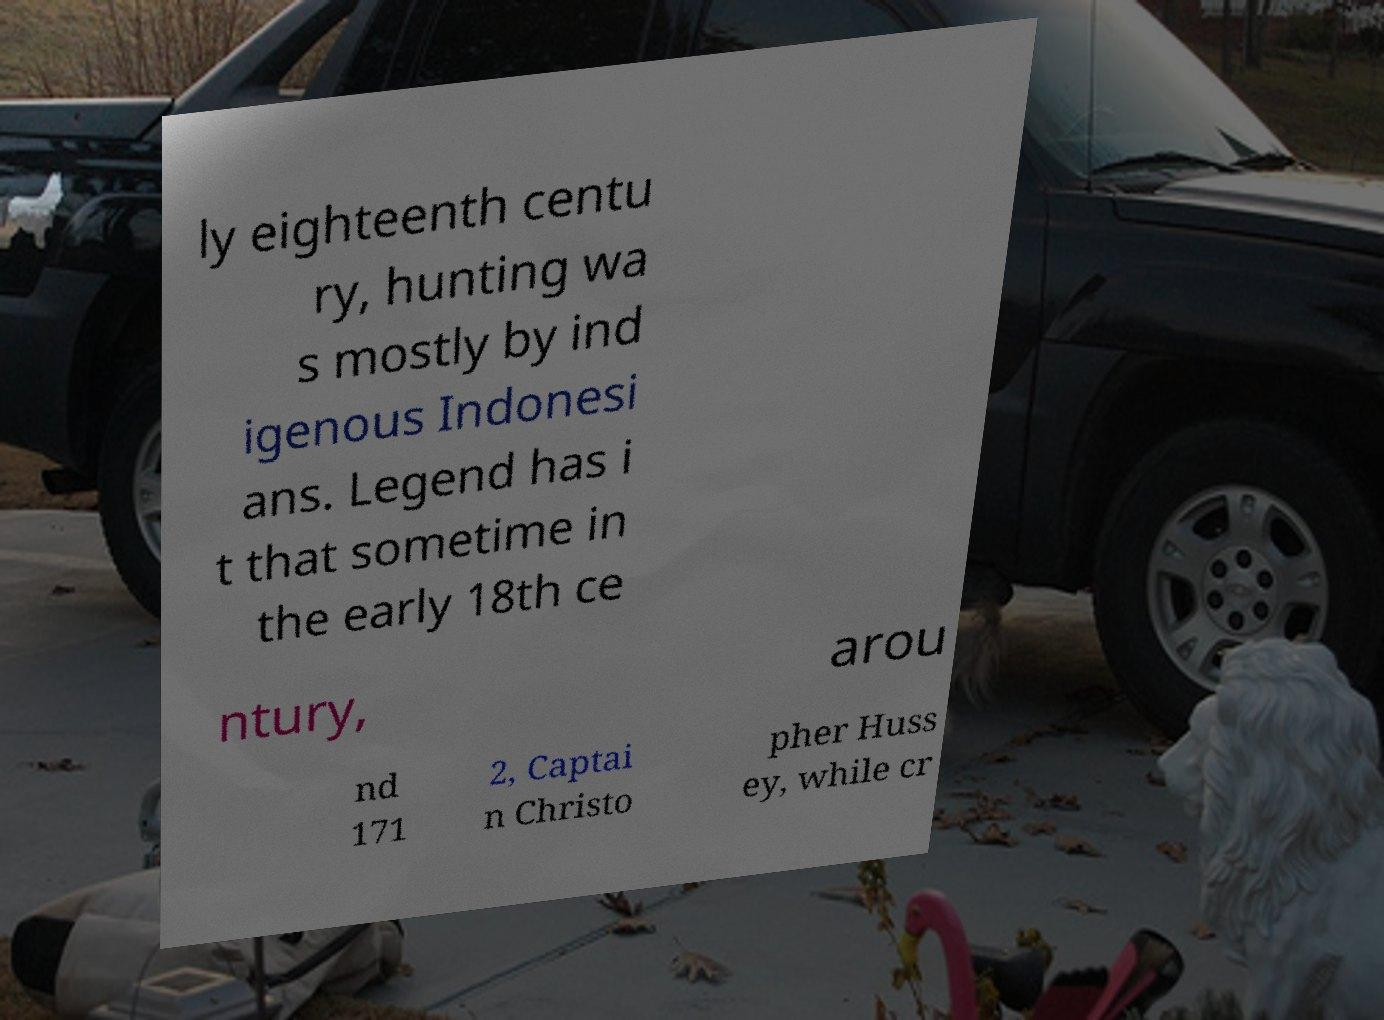For documentation purposes, I need the text within this image transcribed. Could you provide that? ly eighteenth centu ry, hunting wa s mostly by ind igenous Indonesi ans. Legend has i t that sometime in the early 18th ce ntury, arou nd 171 2, Captai n Christo pher Huss ey, while cr 